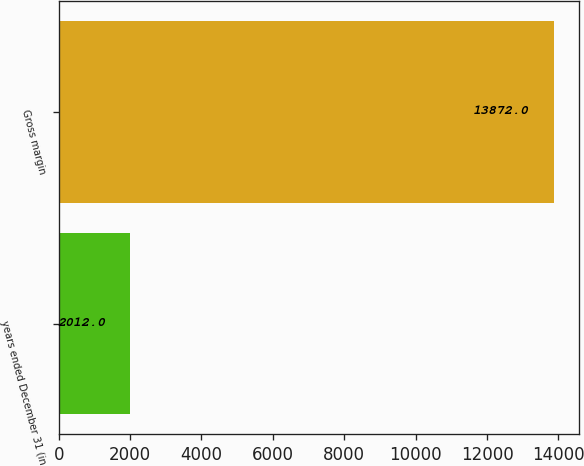<chart> <loc_0><loc_0><loc_500><loc_500><bar_chart><fcel>years ended December 31 (in<fcel>Gross margin<nl><fcel>2012<fcel>13872<nl></chart> 